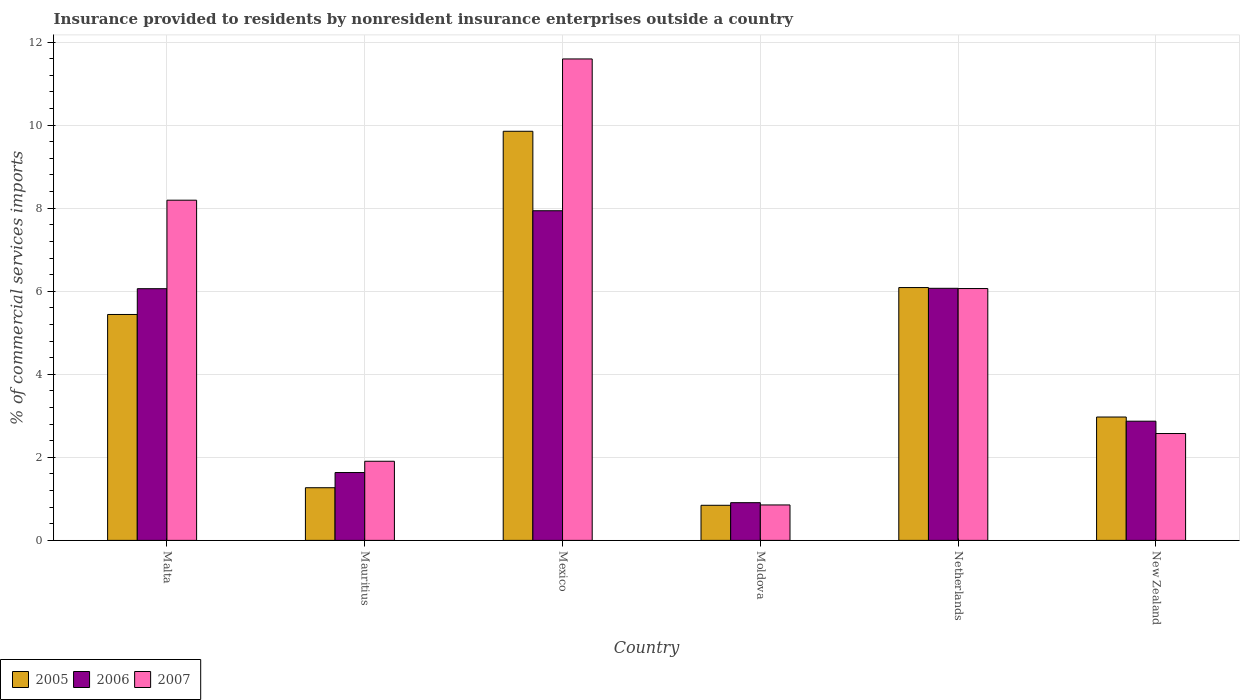Are the number of bars per tick equal to the number of legend labels?
Offer a very short reply. Yes. How many bars are there on the 5th tick from the left?
Provide a succinct answer. 3. What is the label of the 2nd group of bars from the left?
Give a very brief answer. Mauritius. What is the Insurance provided to residents in 2007 in Netherlands?
Your response must be concise. 6.06. Across all countries, what is the maximum Insurance provided to residents in 2007?
Your answer should be compact. 11.59. Across all countries, what is the minimum Insurance provided to residents in 2007?
Ensure brevity in your answer.  0.85. In which country was the Insurance provided to residents in 2006 minimum?
Make the answer very short. Moldova. What is the total Insurance provided to residents in 2006 in the graph?
Offer a terse response. 25.48. What is the difference between the Insurance provided to residents in 2005 in Malta and that in Mexico?
Provide a short and direct response. -4.41. What is the difference between the Insurance provided to residents in 2006 in New Zealand and the Insurance provided to residents in 2007 in Mexico?
Your answer should be compact. -8.72. What is the average Insurance provided to residents in 2005 per country?
Provide a short and direct response. 4.41. What is the difference between the Insurance provided to residents of/in 2006 and Insurance provided to residents of/in 2007 in Malta?
Offer a terse response. -2.13. In how many countries, is the Insurance provided to residents in 2006 greater than 9.6 %?
Make the answer very short. 0. What is the ratio of the Insurance provided to residents in 2007 in Mauritius to that in Moldova?
Offer a terse response. 2.23. Is the difference between the Insurance provided to residents in 2006 in Malta and New Zealand greater than the difference between the Insurance provided to residents in 2007 in Malta and New Zealand?
Provide a short and direct response. No. What is the difference between the highest and the second highest Insurance provided to residents in 2007?
Ensure brevity in your answer.  -3.4. What is the difference between the highest and the lowest Insurance provided to residents in 2007?
Make the answer very short. 10.74. In how many countries, is the Insurance provided to residents in 2005 greater than the average Insurance provided to residents in 2005 taken over all countries?
Make the answer very short. 3. What does the 3rd bar from the right in Mexico represents?
Provide a short and direct response. 2005. How many countries are there in the graph?
Provide a succinct answer. 6. What is the difference between two consecutive major ticks on the Y-axis?
Keep it short and to the point. 2. Are the values on the major ticks of Y-axis written in scientific E-notation?
Offer a terse response. No. Does the graph contain any zero values?
Offer a very short reply. No. How many legend labels are there?
Provide a short and direct response. 3. How are the legend labels stacked?
Ensure brevity in your answer.  Horizontal. What is the title of the graph?
Your answer should be compact. Insurance provided to residents by nonresident insurance enterprises outside a country. What is the label or title of the X-axis?
Your answer should be compact. Country. What is the label or title of the Y-axis?
Give a very brief answer. % of commercial services imports. What is the % of commercial services imports of 2005 in Malta?
Your response must be concise. 5.44. What is the % of commercial services imports of 2006 in Malta?
Keep it short and to the point. 6.06. What is the % of commercial services imports in 2007 in Malta?
Make the answer very short. 8.19. What is the % of commercial services imports in 2005 in Mauritius?
Provide a succinct answer. 1.27. What is the % of commercial services imports in 2006 in Mauritius?
Make the answer very short. 1.63. What is the % of commercial services imports in 2007 in Mauritius?
Provide a succinct answer. 1.91. What is the % of commercial services imports of 2005 in Mexico?
Ensure brevity in your answer.  9.85. What is the % of commercial services imports in 2006 in Mexico?
Your answer should be compact. 7.94. What is the % of commercial services imports of 2007 in Mexico?
Offer a very short reply. 11.59. What is the % of commercial services imports in 2005 in Moldova?
Offer a very short reply. 0.85. What is the % of commercial services imports of 2006 in Moldova?
Offer a terse response. 0.91. What is the % of commercial services imports of 2007 in Moldova?
Your response must be concise. 0.85. What is the % of commercial services imports in 2005 in Netherlands?
Provide a succinct answer. 6.09. What is the % of commercial services imports in 2006 in Netherlands?
Provide a short and direct response. 6.07. What is the % of commercial services imports in 2007 in Netherlands?
Give a very brief answer. 6.06. What is the % of commercial services imports in 2005 in New Zealand?
Ensure brevity in your answer.  2.97. What is the % of commercial services imports of 2006 in New Zealand?
Make the answer very short. 2.87. What is the % of commercial services imports in 2007 in New Zealand?
Give a very brief answer. 2.57. Across all countries, what is the maximum % of commercial services imports of 2005?
Your response must be concise. 9.85. Across all countries, what is the maximum % of commercial services imports in 2006?
Keep it short and to the point. 7.94. Across all countries, what is the maximum % of commercial services imports of 2007?
Give a very brief answer. 11.59. Across all countries, what is the minimum % of commercial services imports in 2005?
Ensure brevity in your answer.  0.85. Across all countries, what is the minimum % of commercial services imports in 2006?
Your response must be concise. 0.91. Across all countries, what is the minimum % of commercial services imports in 2007?
Give a very brief answer. 0.85. What is the total % of commercial services imports of 2005 in the graph?
Your answer should be very brief. 26.46. What is the total % of commercial services imports in 2006 in the graph?
Give a very brief answer. 25.48. What is the total % of commercial services imports in 2007 in the graph?
Provide a succinct answer. 31.18. What is the difference between the % of commercial services imports in 2005 in Malta and that in Mauritius?
Provide a succinct answer. 4.17. What is the difference between the % of commercial services imports in 2006 in Malta and that in Mauritius?
Ensure brevity in your answer.  4.43. What is the difference between the % of commercial services imports of 2007 in Malta and that in Mauritius?
Your response must be concise. 6.29. What is the difference between the % of commercial services imports in 2005 in Malta and that in Mexico?
Your answer should be compact. -4.41. What is the difference between the % of commercial services imports in 2006 in Malta and that in Mexico?
Give a very brief answer. -1.88. What is the difference between the % of commercial services imports of 2007 in Malta and that in Mexico?
Offer a terse response. -3.4. What is the difference between the % of commercial services imports in 2005 in Malta and that in Moldova?
Provide a succinct answer. 4.59. What is the difference between the % of commercial services imports in 2006 in Malta and that in Moldova?
Give a very brief answer. 5.15. What is the difference between the % of commercial services imports of 2007 in Malta and that in Moldova?
Ensure brevity in your answer.  7.34. What is the difference between the % of commercial services imports of 2005 in Malta and that in Netherlands?
Give a very brief answer. -0.65. What is the difference between the % of commercial services imports in 2006 in Malta and that in Netherlands?
Offer a very short reply. -0.01. What is the difference between the % of commercial services imports of 2007 in Malta and that in Netherlands?
Your answer should be very brief. 2.13. What is the difference between the % of commercial services imports in 2005 in Malta and that in New Zealand?
Provide a short and direct response. 2.47. What is the difference between the % of commercial services imports in 2006 in Malta and that in New Zealand?
Keep it short and to the point. 3.19. What is the difference between the % of commercial services imports in 2007 in Malta and that in New Zealand?
Your answer should be very brief. 5.62. What is the difference between the % of commercial services imports of 2005 in Mauritius and that in Mexico?
Ensure brevity in your answer.  -8.58. What is the difference between the % of commercial services imports of 2006 in Mauritius and that in Mexico?
Provide a short and direct response. -6.3. What is the difference between the % of commercial services imports of 2007 in Mauritius and that in Mexico?
Your answer should be compact. -9.69. What is the difference between the % of commercial services imports in 2005 in Mauritius and that in Moldova?
Provide a succinct answer. 0.42. What is the difference between the % of commercial services imports in 2006 in Mauritius and that in Moldova?
Make the answer very short. 0.73. What is the difference between the % of commercial services imports of 2007 in Mauritius and that in Moldova?
Give a very brief answer. 1.05. What is the difference between the % of commercial services imports of 2005 in Mauritius and that in Netherlands?
Offer a very short reply. -4.82. What is the difference between the % of commercial services imports of 2006 in Mauritius and that in Netherlands?
Your answer should be compact. -4.44. What is the difference between the % of commercial services imports of 2007 in Mauritius and that in Netherlands?
Give a very brief answer. -4.16. What is the difference between the % of commercial services imports in 2005 in Mauritius and that in New Zealand?
Offer a terse response. -1.7. What is the difference between the % of commercial services imports in 2006 in Mauritius and that in New Zealand?
Keep it short and to the point. -1.24. What is the difference between the % of commercial services imports of 2007 in Mauritius and that in New Zealand?
Ensure brevity in your answer.  -0.67. What is the difference between the % of commercial services imports of 2005 in Mexico and that in Moldova?
Make the answer very short. 9.01. What is the difference between the % of commercial services imports in 2006 in Mexico and that in Moldova?
Keep it short and to the point. 7.03. What is the difference between the % of commercial services imports of 2007 in Mexico and that in Moldova?
Your answer should be very brief. 10.74. What is the difference between the % of commercial services imports in 2005 in Mexico and that in Netherlands?
Offer a very short reply. 3.76. What is the difference between the % of commercial services imports in 2006 in Mexico and that in Netherlands?
Your answer should be compact. 1.87. What is the difference between the % of commercial services imports of 2007 in Mexico and that in Netherlands?
Provide a short and direct response. 5.53. What is the difference between the % of commercial services imports in 2005 in Mexico and that in New Zealand?
Your answer should be compact. 6.88. What is the difference between the % of commercial services imports in 2006 in Mexico and that in New Zealand?
Offer a terse response. 5.07. What is the difference between the % of commercial services imports of 2007 in Mexico and that in New Zealand?
Your answer should be very brief. 9.02. What is the difference between the % of commercial services imports of 2005 in Moldova and that in Netherlands?
Make the answer very short. -5.24. What is the difference between the % of commercial services imports in 2006 in Moldova and that in Netherlands?
Ensure brevity in your answer.  -5.16. What is the difference between the % of commercial services imports of 2007 in Moldova and that in Netherlands?
Give a very brief answer. -5.21. What is the difference between the % of commercial services imports in 2005 in Moldova and that in New Zealand?
Give a very brief answer. -2.13. What is the difference between the % of commercial services imports of 2006 in Moldova and that in New Zealand?
Your answer should be very brief. -1.96. What is the difference between the % of commercial services imports in 2007 in Moldova and that in New Zealand?
Give a very brief answer. -1.72. What is the difference between the % of commercial services imports of 2005 in Netherlands and that in New Zealand?
Your answer should be compact. 3.12. What is the difference between the % of commercial services imports in 2006 in Netherlands and that in New Zealand?
Provide a succinct answer. 3.2. What is the difference between the % of commercial services imports of 2007 in Netherlands and that in New Zealand?
Your answer should be very brief. 3.49. What is the difference between the % of commercial services imports in 2005 in Malta and the % of commercial services imports in 2006 in Mauritius?
Your response must be concise. 3.81. What is the difference between the % of commercial services imports of 2005 in Malta and the % of commercial services imports of 2007 in Mauritius?
Give a very brief answer. 3.53. What is the difference between the % of commercial services imports of 2006 in Malta and the % of commercial services imports of 2007 in Mauritius?
Offer a terse response. 4.16. What is the difference between the % of commercial services imports of 2005 in Malta and the % of commercial services imports of 2006 in Mexico?
Your answer should be compact. -2.5. What is the difference between the % of commercial services imports of 2005 in Malta and the % of commercial services imports of 2007 in Mexico?
Make the answer very short. -6.15. What is the difference between the % of commercial services imports in 2006 in Malta and the % of commercial services imports in 2007 in Mexico?
Keep it short and to the point. -5.53. What is the difference between the % of commercial services imports in 2005 in Malta and the % of commercial services imports in 2006 in Moldova?
Give a very brief answer. 4.53. What is the difference between the % of commercial services imports of 2005 in Malta and the % of commercial services imports of 2007 in Moldova?
Give a very brief answer. 4.59. What is the difference between the % of commercial services imports of 2006 in Malta and the % of commercial services imports of 2007 in Moldova?
Ensure brevity in your answer.  5.21. What is the difference between the % of commercial services imports of 2005 in Malta and the % of commercial services imports of 2006 in Netherlands?
Offer a terse response. -0.63. What is the difference between the % of commercial services imports in 2005 in Malta and the % of commercial services imports in 2007 in Netherlands?
Ensure brevity in your answer.  -0.62. What is the difference between the % of commercial services imports of 2006 in Malta and the % of commercial services imports of 2007 in Netherlands?
Make the answer very short. -0. What is the difference between the % of commercial services imports in 2005 in Malta and the % of commercial services imports in 2006 in New Zealand?
Your response must be concise. 2.57. What is the difference between the % of commercial services imports in 2005 in Malta and the % of commercial services imports in 2007 in New Zealand?
Your answer should be compact. 2.87. What is the difference between the % of commercial services imports in 2006 in Malta and the % of commercial services imports in 2007 in New Zealand?
Your response must be concise. 3.49. What is the difference between the % of commercial services imports of 2005 in Mauritius and the % of commercial services imports of 2006 in Mexico?
Your response must be concise. -6.67. What is the difference between the % of commercial services imports of 2005 in Mauritius and the % of commercial services imports of 2007 in Mexico?
Ensure brevity in your answer.  -10.33. What is the difference between the % of commercial services imports of 2006 in Mauritius and the % of commercial services imports of 2007 in Mexico?
Keep it short and to the point. -9.96. What is the difference between the % of commercial services imports of 2005 in Mauritius and the % of commercial services imports of 2006 in Moldova?
Offer a very short reply. 0.36. What is the difference between the % of commercial services imports of 2005 in Mauritius and the % of commercial services imports of 2007 in Moldova?
Keep it short and to the point. 0.41. What is the difference between the % of commercial services imports of 2006 in Mauritius and the % of commercial services imports of 2007 in Moldova?
Ensure brevity in your answer.  0.78. What is the difference between the % of commercial services imports in 2005 in Mauritius and the % of commercial services imports in 2006 in Netherlands?
Give a very brief answer. -4.8. What is the difference between the % of commercial services imports in 2005 in Mauritius and the % of commercial services imports in 2007 in Netherlands?
Ensure brevity in your answer.  -4.8. What is the difference between the % of commercial services imports in 2006 in Mauritius and the % of commercial services imports in 2007 in Netherlands?
Your response must be concise. -4.43. What is the difference between the % of commercial services imports of 2005 in Mauritius and the % of commercial services imports of 2006 in New Zealand?
Your answer should be very brief. -1.6. What is the difference between the % of commercial services imports of 2005 in Mauritius and the % of commercial services imports of 2007 in New Zealand?
Provide a short and direct response. -1.31. What is the difference between the % of commercial services imports of 2006 in Mauritius and the % of commercial services imports of 2007 in New Zealand?
Your answer should be compact. -0.94. What is the difference between the % of commercial services imports of 2005 in Mexico and the % of commercial services imports of 2006 in Moldova?
Provide a short and direct response. 8.94. What is the difference between the % of commercial services imports of 2005 in Mexico and the % of commercial services imports of 2007 in Moldova?
Ensure brevity in your answer.  9. What is the difference between the % of commercial services imports of 2006 in Mexico and the % of commercial services imports of 2007 in Moldova?
Make the answer very short. 7.08. What is the difference between the % of commercial services imports in 2005 in Mexico and the % of commercial services imports in 2006 in Netherlands?
Your answer should be very brief. 3.78. What is the difference between the % of commercial services imports in 2005 in Mexico and the % of commercial services imports in 2007 in Netherlands?
Offer a very short reply. 3.79. What is the difference between the % of commercial services imports in 2006 in Mexico and the % of commercial services imports in 2007 in Netherlands?
Give a very brief answer. 1.87. What is the difference between the % of commercial services imports in 2005 in Mexico and the % of commercial services imports in 2006 in New Zealand?
Your answer should be very brief. 6.98. What is the difference between the % of commercial services imports in 2005 in Mexico and the % of commercial services imports in 2007 in New Zealand?
Provide a succinct answer. 7.28. What is the difference between the % of commercial services imports of 2006 in Mexico and the % of commercial services imports of 2007 in New Zealand?
Provide a short and direct response. 5.36. What is the difference between the % of commercial services imports of 2005 in Moldova and the % of commercial services imports of 2006 in Netherlands?
Provide a succinct answer. -5.23. What is the difference between the % of commercial services imports in 2005 in Moldova and the % of commercial services imports in 2007 in Netherlands?
Give a very brief answer. -5.22. What is the difference between the % of commercial services imports of 2006 in Moldova and the % of commercial services imports of 2007 in Netherlands?
Provide a short and direct response. -5.16. What is the difference between the % of commercial services imports of 2005 in Moldova and the % of commercial services imports of 2006 in New Zealand?
Keep it short and to the point. -2.03. What is the difference between the % of commercial services imports in 2005 in Moldova and the % of commercial services imports in 2007 in New Zealand?
Offer a very short reply. -1.73. What is the difference between the % of commercial services imports of 2006 in Moldova and the % of commercial services imports of 2007 in New Zealand?
Keep it short and to the point. -1.67. What is the difference between the % of commercial services imports in 2005 in Netherlands and the % of commercial services imports in 2006 in New Zealand?
Offer a very short reply. 3.22. What is the difference between the % of commercial services imports of 2005 in Netherlands and the % of commercial services imports of 2007 in New Zealand?
Give a very brief answer. 3.52. What is the difference between the % of commercial services imports of 2006 in Netherlands and the % of commercial services imports of 2007 in New Zealand?
Make the answer very short. 3.5. What is the average % of commercial services imports in 2005 per country?
Your response must be concise. 4.41. What is the average % of commercial services imports of 2006 per country?
Provide a succinct answer. 4.25. What is the average % of commercial services imports in 2007 per country?
Offer a terse response. 5.2. What is the difference between the % of commercial services imports of 2005 and % of commercial services imports of 2006 in Malta?
Your answer should be very brief. -0.62. What is the difference between the % of commercial services imports in 2005 and % of commercial services imports in 2007 in Malta?
Offer a very short reply. -2.75. What is the difference between the % of commercial services imports of 2006 and % of commercial services imports of 2007 in Malta?
Ensure brevity in your answer.  -2.13. What is the difference between the % of commercial services imports of 2005 and % of commercial services imports of 2006 in Mauritius?
Ensure brevity in your answer.  -0.37. What is the difference between the % of commercial services imports in 2005 and % of commercial services imports in 2007 in Mauritius?
Keep it short and to the point. -0.64. What is the difference between the % of commercial services imports in 2006 and % of commercial services imports in 2007 in Mauritius?
Keep it short and to the point. -0.27. What is the difference between the % of commercial services imports of 2005 and % of commercial services imports of 2006 in Mexico?
Offer a terse response. 1.91. What is the difference between the % of commercial services imports of 2005 and % of commercial services imports of 2007 in Mexico?
Your answer should be very brief. -1.74. What is the difference between the % of commercial services imports in 2006 and % of commercial services imports in 2007 in Mexico?
Provide a short and direct response. -3.66. What is the difference between the % of commercial services imports in 2005 and % of commercial services imports in 2006 in Moldova?
Give a very brief answer. -0.06. What is the difference between the % of commercial services imports of 2005 and % of commercial services imports of 2007 in Moldova?
Provide a succinct answer. -0.01. What is the difference between the % of commercial services imports in 2006 and % of commercial services imports in 2007 in Moldova?
Make the answer very short. 0.05. What is the difference between the % of commercial services imports of 2005 and % of commercial services imports of 2006 in Netherlands?
Your answer should be compact. 0.02. What is the difference between the % of commercial services imports of 2005 and % of commercial services imports of 2007 in Netherlands?
Offer a terse response. 0.02. What is the difference between the % of commercial services imports in 2006 and % of commercial services imports in 2007 in Netherlands?
Ensure brevity in your answer.  0.01. What is the difference between the % of commercial services imports in 2005 and % of commercial services imports in 2006 in New Zealand?
Make the answer very short. 0.1. What is the difference between the % of commercial services imports in 2005 and % of commercial services imports in 2007 in New Zealand?
Keep it short and to the point. 0.4. What is the difference between the % of commercial services imports in 2006 and % of commercial services imports in 2007 in New Zealand?
Provide a succinct answer. 0.3. What is the ratio of the % of commercial services imports in 2005 in Malta to that in Mauritius?
Offer a terse response. 4.29. What is the ratio of the % of commercial services imports of 2006 in Malta to that in Mauritius?
Ensure brevity in your answer.  3.71. What is the ratio of the % of commercial services imports in 2007 in Malta to that in Mauritius?
Provide a succinct answer. 4.3. What is the ratio of the % of commercial services imports of 2005 in Malta to that in Mexico?
Your response must be concise. 0.55. What is the ratio of the % of commercial services imports of 2006 in Malta to that in Mexico?
Make the answer very short. 0.76. What is the ratio of the % of commercial services imports of 2007 in Malta to that in Mexico?
Keep it short and to the point. 0.71. What is the ratio of the % of commercial services imports of 2005 in Malta to that in Moldova?
Provide a short and direct response. 6.44. What is the ratio of the % of commercial services imports in 2006 in Malta to that in Moldova?
Provide a short and direct response. 6.67. What is the ratio of the % of commercial services imports in 2007 in Malta to that in Moldova?
Keep it short and to the point. 9.6. What is the ratio of the % of commercial services imports of 2005 in Malta to that in Netherlands?
Keep it short and to the point. 0.89. What is the ratio of the % of commercial services imports of 2006 in Malta to that in Netherlands?
Provide a short and direct response. 1. What is the ratio of the % of commercial services imports of 2007 in Malta to that in Netherlands?
Provide a short and direct response. 1.35. What is the ratio of the % of commercial services imports of 2005 in Malta to that in New Zealand?
Give a very brief answer. 1.83. What is the ratio of the % of commercial services imports of 2006 in Malta to that in New Zealand?
Ensure brevity in your answer.  2.11. What is the ratio of the % of commercial services imports of 2007 in Malta to that in New Zealand?
Offer a very short reply. 3.18. What is the ratio of the % of commercial services imports of 2005 in Mauritius to that in Mexico?
Offer a terse response. 0.13. What is the ratio of the % of commercial services imports of 2006 in Mauritius to that in Mexico?
Your response must be concise. 0.21. What is the ratio of the % of commercial services imports in 2007 in Mauritius to that in Mexico?
Give a very brief answer. 0.16. What is the ratio of the % of commercial services imports of 2005 in Mauritius to that in Moldova?
Offer a terse response. 1.5. What is the ratio of the % of commercial services imports of 2006 in Mauritius to that in Moldova?
Give a very brief answer. 1.8. What is the ratio of the % of commercial services imports of 2007 in Mauritius to that in Moldova?
Offer a terse response. 2.23. What is the ratio of the % of commercial services imports in 2005 in Mauritius to that in Netherlands?
Provide a short and direct response. 0.21. What is the ratio of the % of commercial services imports of 2006 in Mauritius to that in Netherlands?
Make the answer very short. 0.27. What is the ratio of the % of commercial services imports in 2007 in Mauritius to that in Netherlands?
Provide a succinct answer. 0.31. What is the ratio of the % of commercial services imports in 2005 in Mauritius to that in New Zealand?
Give a very brief answer. 0.43. What is the ratio of the % of commercial services imports of 2006 in Mauritius to that in New Zealand?
Provide a succinct answer. 0.57. What is the ratio of the % of commercial services imports of 2007 in Mauritius to that in New Zealand?
Ensure brevity in your answer.  0.74. What is the ratio of the % of commercial services imports of 2005 in Mexico to that in Moldova?
Provide a short and direct response. 11.66. What is the ratio of the % of commercial services imports in 2006 in Mexico to that in Moldova?
Offer a terse response. 8.74. What is the ratio of the % of commercial services imports in 2007 in Mexico to that in Moldova?
Your answer should be compact. 13.58. What is the ratio of the % of commercial services imports in 2005 in Mexico to that in Netherlands?
Offer a very short reply. 1.62. What is the ratio of the % of commercial services imports in 2006 in Mexico to that in Netherlands?
Make the answer very short. 1.31. What is the ratio of the % of commercial services imports in 2007 in Mexico to that in Netherlands?
Your response must be concise. 1.91. What is the ratio of the % of commercial services imports in 2005 in Mexico to that in New Zealand?
Keep it short and to the point. 3.32. What is the ratio of the % of commercial services imports of 2006 in Mexico to that in New Zealand?
Keep it short and to the point. 2.77. What is the ratio of the % of commercial services imports in 2007 in Mexico to that in New Zealand?
Offer a very short reply. 4.51. What is the ratio of the % of commercial services imports in 2005 in Moldova to that in Netherlands?
Give a very brief answer. 0.14. What is the ratio of the % of commercial services imports in 2006 in Moldova to that in Netherlands?
Your answer should be very brief. 0.15. What is the ratio of the % of commercial services imports of 2007 in Moldova to that in Netherlands?
Your response must be concise. 0.14. What is the ratio of the % of commercial services imports in 2005 in Moldova to that in New Zealand?
Ensure brevity in your answer.  0.28. What is the ratio of the % of commercial services imports of 2006 in Moldova to that in New Zealand?
Ensure brevity in your answer.  0.32. What is the ratio of the % of commercial services imports in 2007 in Moldova to that in New Zealand?
Offer a very short reply. 0.33. What is the ratio of the % of commercial services imports of 2005 in Netherlands to that in New Zealand?
Offer a very short reply. 2.05. What is the ratio of the % of commercial services imports of 2006 in Netherlands to that in New Zealand?
Offer a very short reply. 2.12. What is the ratio of the % of commercial services imports in 2007 in Netherlands to that in New Zealand?
Your response must be concise. 2.36. What is the difference between the highest and the second highest % of commercial services imports of 2005?
Offer a terse response. 3.76. What is the difference between the highest and the second highest % of commercial services imports of 2006?
Provide a succinct answer. 1.87. What is the difference between the highest and the second highest % of commercial services imports in 2007?
Your response must be concise. 3.4. What is the difference between the highest and the lowest % of commercial services imports in 2005?
Your answer should be compact. 9.01. What is the difference between the highest and the lowest % of commercial services imports of 2006?
Your response must be concise. 7.03. What is the difference between the highest and the lowest % of commercial services imports in 2007?
Make the answer very short. 10.74. 